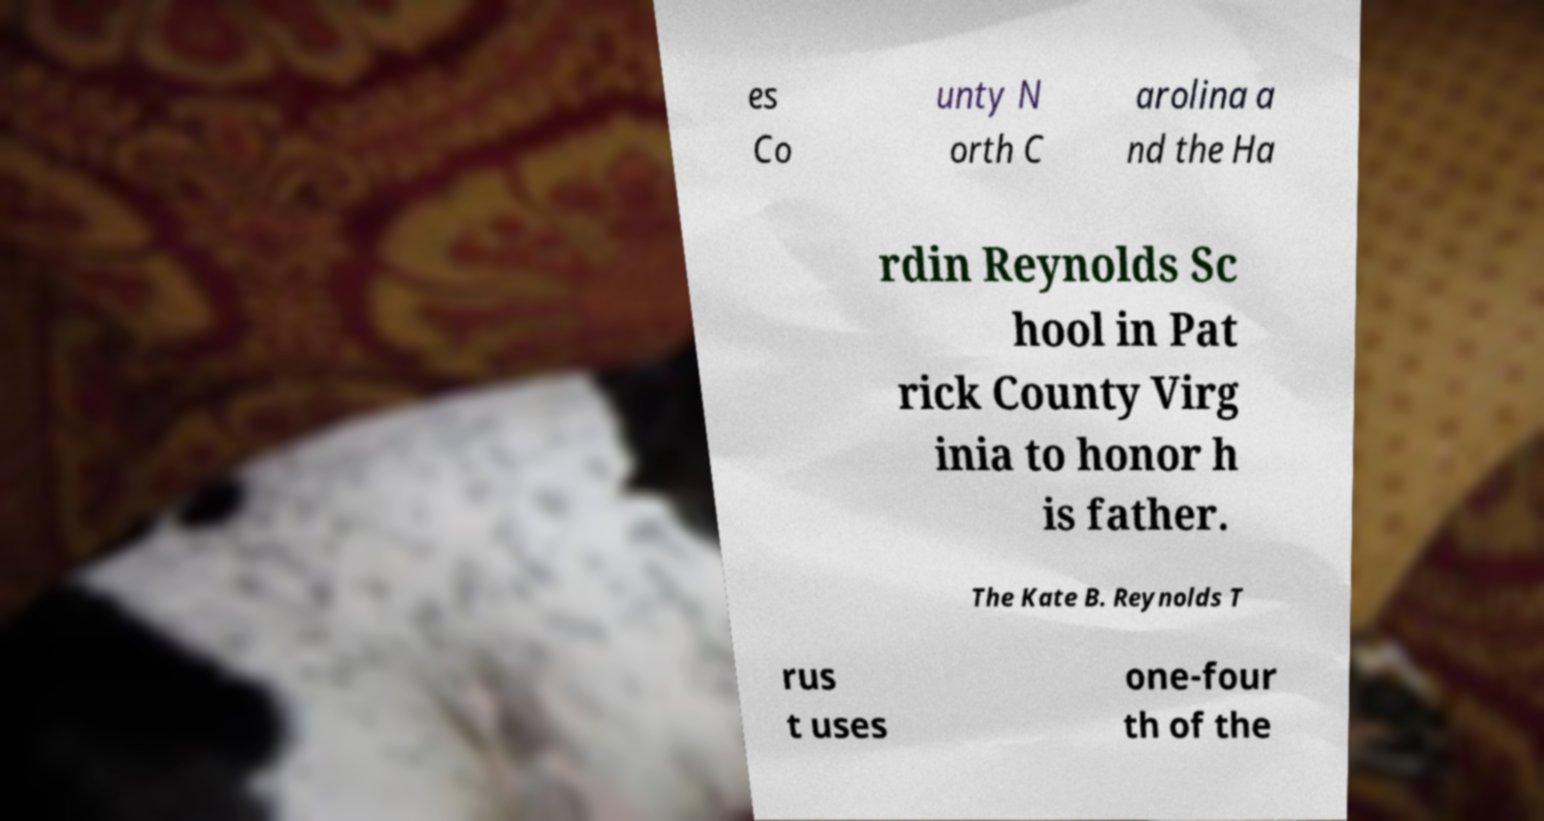There's text embedded in this image that I need extracted. Can you transcribe it verbatim? es Co unty N orth C arolina a nd the Ha rdin Reynolds Sc hool in Pat rick County Virg inia to honor h is father. The Kate B. Reynolds T rus t uses one-four th of the 